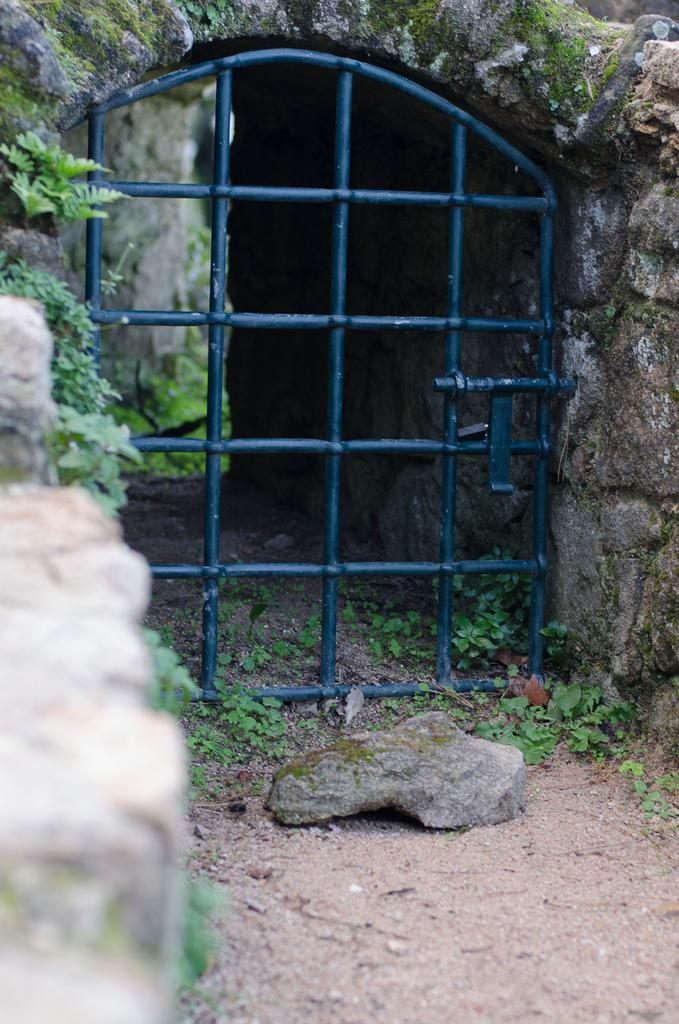What structure can be seen in the image? There is a gate in the image. What type of natural elements are present in the image? There are plants and rocks in the image. How many chickens can be seen in the image? There are no chickens present in the image. What shape is the bee in the image? There is no bee present in the image. 